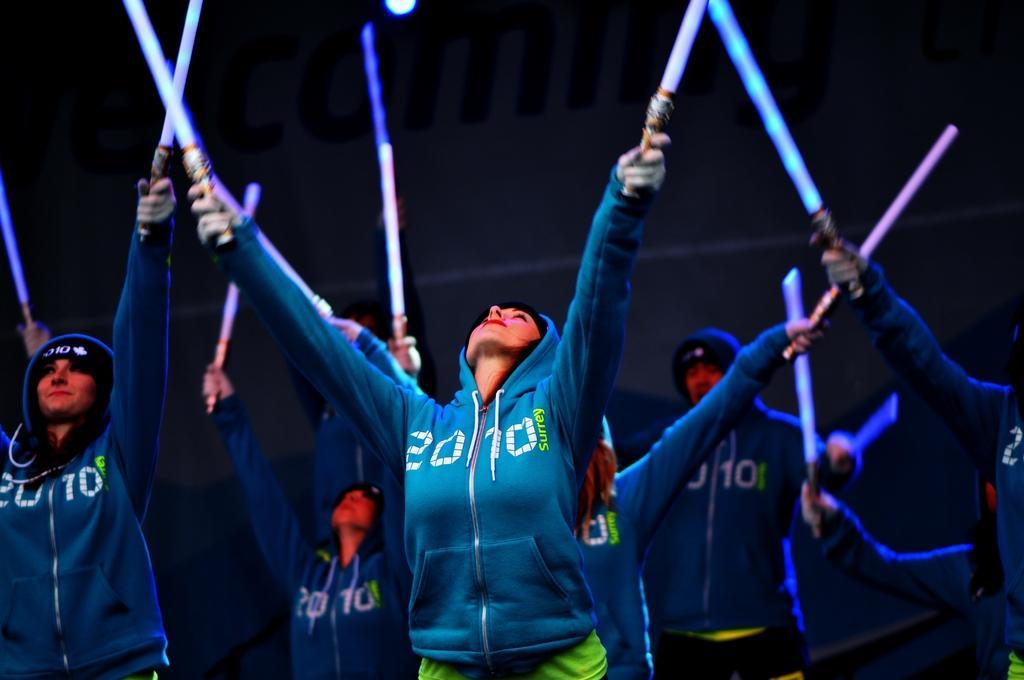Can you describe this image briefly? There are group of people standing and holding laser lights in their hands. 